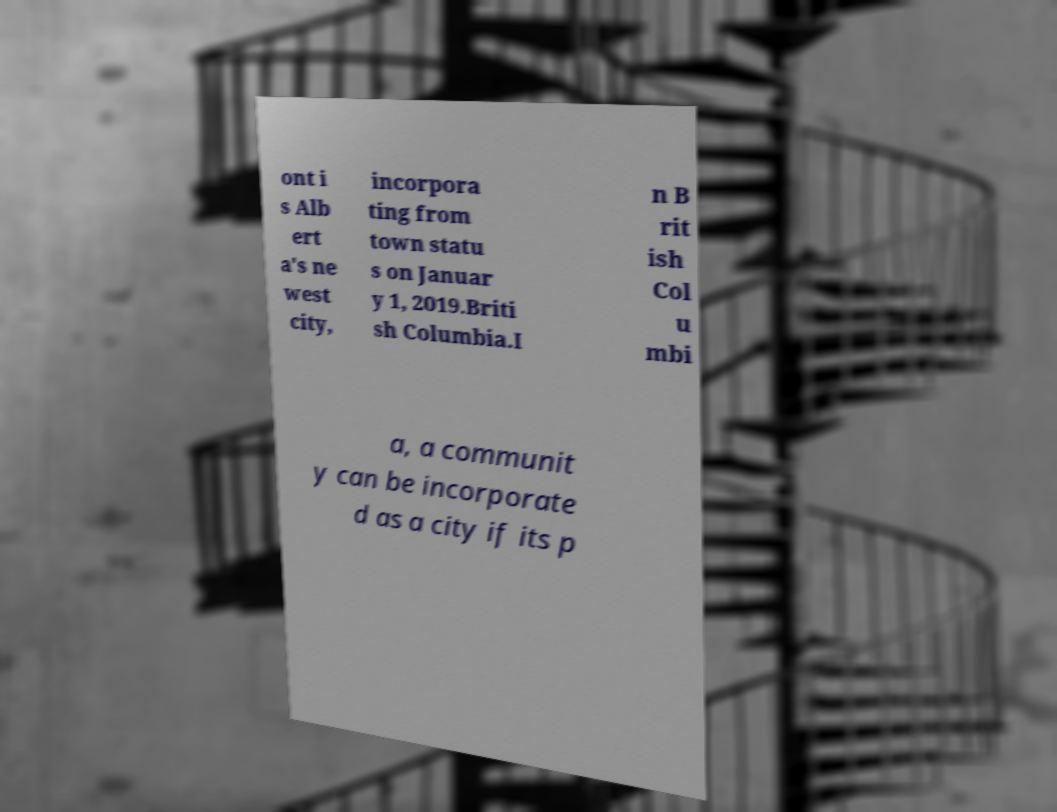Please read and relay the text visible in this image. What does it say? ont i s Alb ert a's ne west city, incorpora ting from town statu s on Januar y 1, 2019.Briti sh Columbia.I n B rit ish Col u mbi a, a communit y can be incorporate d as a city if its p 